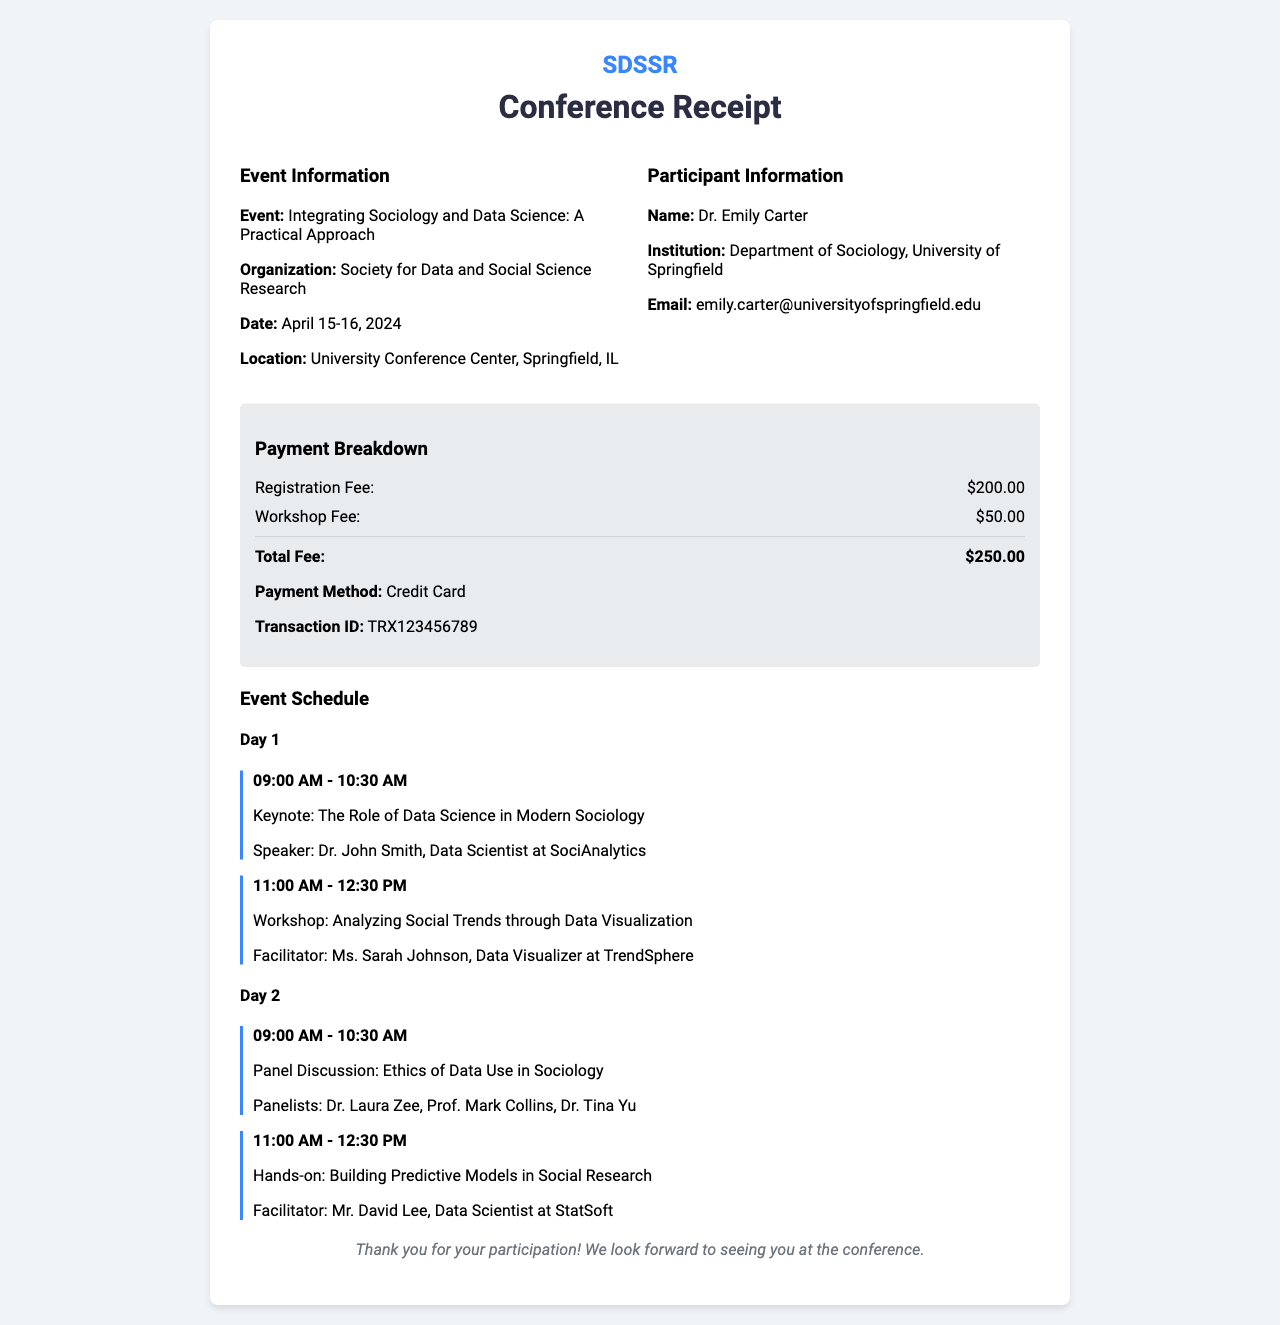What is the participant's name? The participant's name is listed in the document under Participant Information.
Answer: Dr. Emily Carter What is the organization hosting the conference? The organization is mentioned in the Event Information section of the document.
Answer: Society for Data and Social Science Research What is the total fee for the conference? The total fee is calculated from the payment breakdown detailed in the document.
Answer: $250.00 What is the transaction ID for the payment? The transaction ID is provided in the payment breakdown section of the document.
Answer: TRX123456789 What is the date of the conference? The date is explicitly mentioned in the Event Information part of the document.
Answer: April 15-16, 2024 Who is the facilitator for the hands-on session? The facilitator is listed in the Day 2 schedule of the event.
Answer: Mr. David Lee What time does the keynote session start? The starting time for the keynote session is provided in the Day 1 schedule section.
Answer: 09:00 AM In which city is the conference being held? The city is specified in the Event Information section of the document.
Answer: Springfield, IL What is the workshop fee? The workshop fee is detailed in the payment breakdown of the document.
Answer: $50.00 